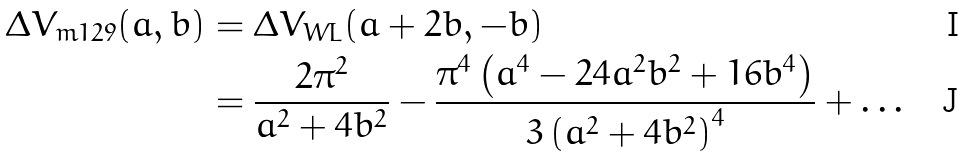<formula> <loc_0><loc_0><loc_500><loc_500>\Delta V _ { m 1 2 9 } ( a , b ) & = \Delta V _ { W L } ( a + 2 b , - b ) \\ & = \frac { 2 \pi ^ { 2 } } { a ^ { 2 } + 4 b ^ { 2 } } - \frac { \pi ^ { 4 } \left ( a ^ { 4 } - 2 4 a ^ { 2 } b ^ { 2 } + 1 6 b ^ { 4 } \right ) } { 3 \left ( a ^ { 2 } + 4 b ^ { 2 } \right ) ^ { 4 } } + \dots</formula> 